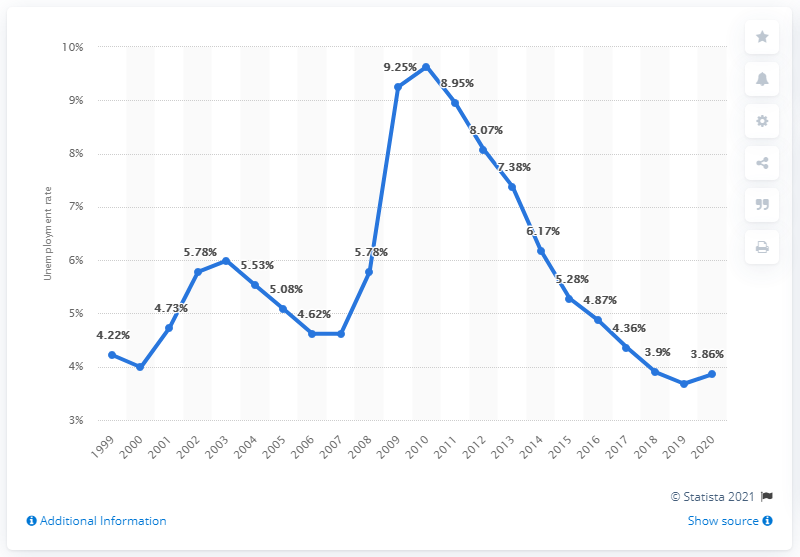Specify some key components in this picture. In 2020, the unemployment rate in the United States was 3.86%. 